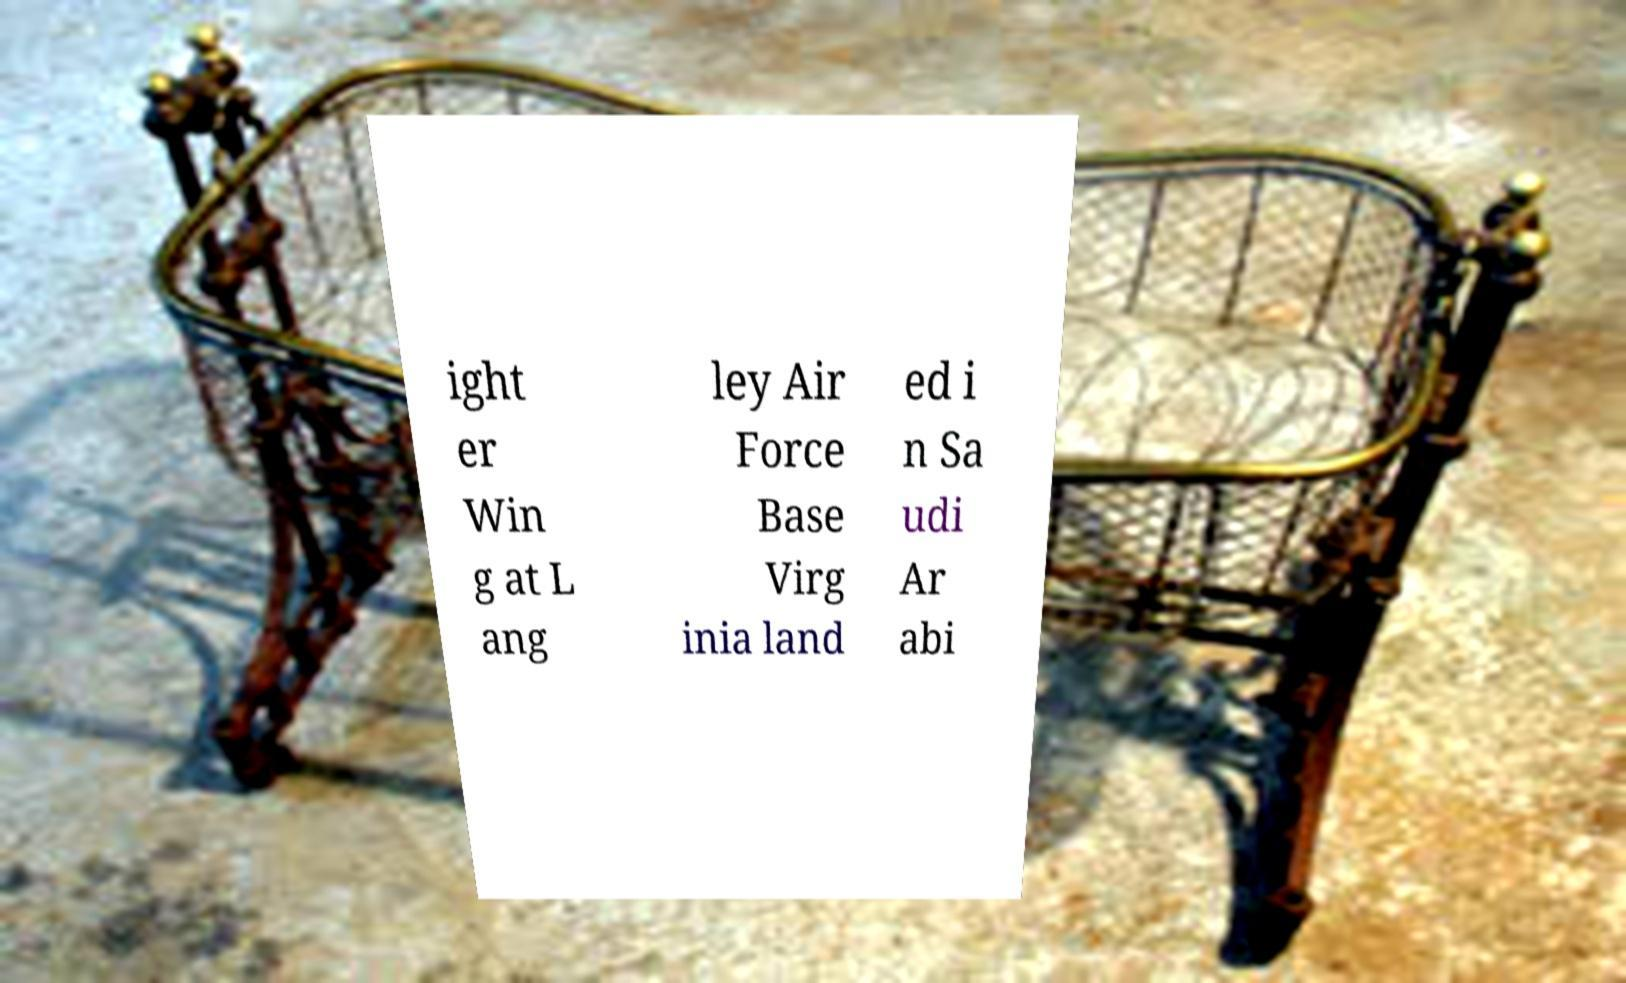Can you read and provide the text displayed in the image?This photo seems to have some interesting text. Can you extract and type it out for me? ight er Win g at L ang ley Air Force Base Virg inia land ed i n Sa udi Ar abi 